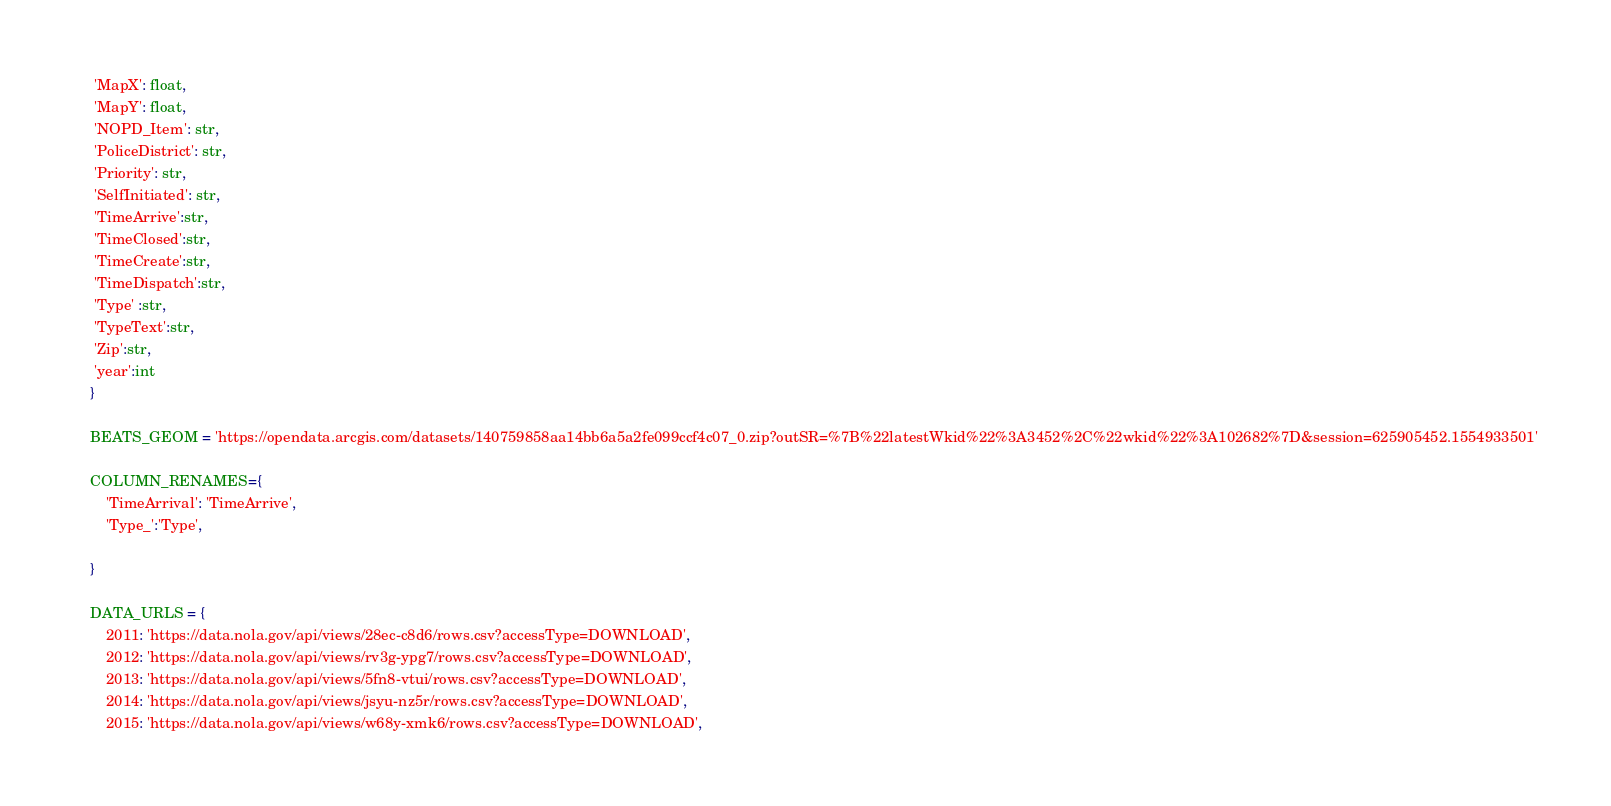Convert code to text. <code><loc_0><loc_0><loc_500><loc_500><_Python_>     'MapX': float,
     'MapY': float, 
     'NOPD_Item': str, 
     'PoliceDistrict': str, 
     'Priority': str, 
     'SelfInitiated': str,
     'TimeArrive':str, 
     'TimeClosed':str, 
     'TimeCreate':str, 
     'TimeDispatch':str, 
     'Type' :str,
     'TypeText':str, 
     'Zip':str, 
     'year':int   
    }
    
    BEATS_GEOM = 'https://opendata.arcgis.com/datasets/140759858aa14bb6a5a2fe099ccf4c07_0.zip?outSR=%7B%22latestWkid%22%3A3452%2C%22wkid%22%3A102682%7D&session=625905452.1554933501'

    COLUMN_RENAMES={
        'TimeArrival': 'TimeArrive',
        'Type_':'Type',
        
    }

    DATA_URLS = {
        2011: 'https://data.nola.gov/api/views/28ec-c8d6/rows.csv?accessType=DOWNLOAD',
        2012: 'https://data.nola.gov/api/views/rv3g-ypg7/rows.csv?accessType=DOWNLOAD',
        2013: 'https://data.nola.gov/api/views/5fn8-vtui/rows.csv?accessType=DOWNLOAD',
        2014: 'https://data.nola.gov/api/views/jsyu-nz5r/rows.csv?accessType=DOWNLOAD',
        2015: 'https://data.nola.gov/api/views/w68y-xmk6/rows.csv?accessType=DOWNLOAD',</code> 